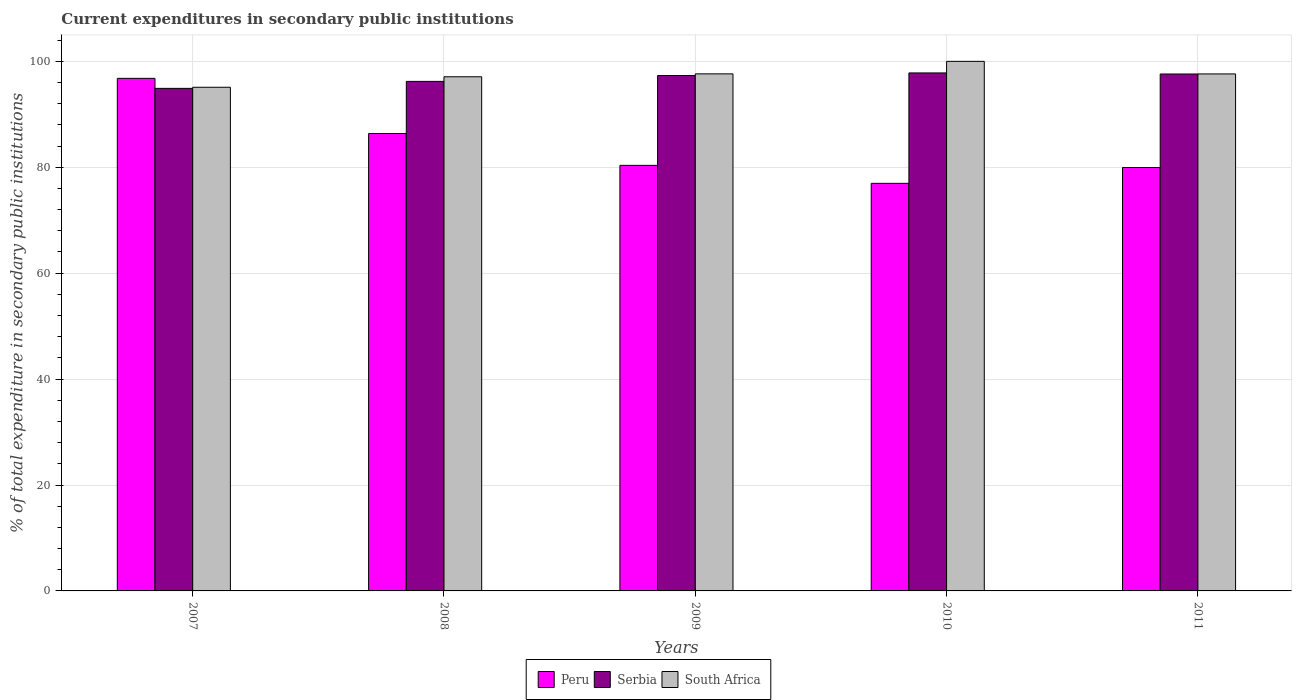How many different coloured bars are there?
Give a very brief answer. 3. Are the number of bars per tick equal to the number of legend labels?
Ensure brevity in your answer.  Yes. How many bars are there on the 3rd tick from the left?
Ensure brevity in your answer.  3. How many bars are there on the 1st tick from the right?
Provide a short and direct response. 3. What is the label of the 5th group of bars from the left?
Keep it short and to the point. 2011. What is the current expenditures in secondary public institutions in Peru in 2007?
Make the answer very short. 96.79. Across all years, what is the maximum current expenditures in secondary public institutions in Peru?
Offer a terse response. 96.79. Across all years, what is the minimum current expenditures in secondary public institutions in Peru?
Provide a succinct answer. 76.97. In which year was the current expenditures in secondary public institutions in Serbia maximum?
Keep it short and to the point. 2010. What is the total current expenditures in secondary public institutions in South Africa in the graph?
Offer a very short reply. 487.46. What is the difference between the current expenditures in secondary public institutions in Serbia in 2007 and that in 2009?
Provide a succinct answer. -2.42. What is the difference between the current expenditures in secondary public institutions in Serbia in 2010 and the current expenditures in secondary public institutions in Peru in 2009?
Provide a short and direct response. 17.45. What is the average current expenditures in secondary public institutions in South Africa per year?
Offer a very short reply. 97.49. In the year 2010, what is the difference between the current expenditures in secondary public institutions in South Africa and current expenditures in secondary public institutions in Serbia?
Provide a short and direct response. 2.19. What is the ratio of the current expenditures in secondary public institutions in Peru in 2007 to that in 2008?
Your answer should be compact. 1.12. What is the difference between the highest and the second highest current expenditures in secondary public institutions in Serbia?
Your answer should be compact. 0.21. What is the difference between the highest and the lowest current expenditures in secondary public institutions in Peru?
Your answer should be very brief. 19.82. Is the sum of the current expenditures in secondary public institutions in South Africa in 2007 and 2010 greater than the maximum current expenditures in secondary public institutions in Serbia across all years?
Your response must be concise. Yes. What does the 1st bar from the left in 2008 represents?
Provide a succinct answer. Peru. What does the 1st bar from the right in 2009 represents?
Your answer should be very brief. South Africa. Is it the case that in every year, the sum of the current expenditures in secondary public institutions in Peru and current expenditures in secondary public institutions in Serbia is greater than the current expenditures in secondary public institutions in South Africa?
Offer a very short reply. Yes. Are all the bars in the graph horizontal?
Your answer should be very brief. No. What is the difference between two consecutive major ticks on the Y-axis?
Your answer should be compact. 20. Does the graph contain any zero values?
Provide a short and direct response. No. Where does the legend appear in the graph?
Provide a succinct answer. Bottom center. What is the title of the graph?
Offer a very short reply. Current expenditures in secondary public institutions. What is the label or title of the X-axis?
Provide a succinct answer. Years. What is the label or title of the Y-axis?
Your answer should be very brief. % of total expenditure in secondary public institutions. What is the % of total expenditure in secondary public institutions of Peru in 2007?
Offer a terse response. 96.79. What is the % of total expenditure in secondary public institutions of Serbia in 2007?
Make the answer very short. 94.9. What is the % of total expenditure in secondary public institutions of South Africa in 2007?
Your answer should be very brief. 95.11. What is the % of total expenditure in secondary public institutions in Peru in 2008?
Offer a terse response. 86.38. What is the % of total expenditure in secondary public institutions in Serbia in 2008?
Keep it short and to the point. 96.22. What is the % of total expenditure in secondary public institutions of South Africa in 2008?
Provide a succinct answer. 97.09. What is the % of total expenditure in secondary public institutions of Peru in 2009?
Provide a succinct answer. 80.36. What is the % of total expenditure in secondary public institutions of Serbia in 2009?
Give a very brief answer. 97.32. What is the % of total expenditure in secondary public institutions of South Africa in 2009?
Keep it short and to the point. 97.64. What is the % of total expenditure in secondary public institutions of Peru in 2010?
Offer a very short reply. 76.97. What is the % of total expenditure in secondary public institutions in Serbia in 2010?
Make the answer very short. 97.81. What is the % of total expenditure in secondary public institutions of South Africa in 2010?
Your answer should be compact. 100. What is the % of total expenditure in secondary public institutions in Peru in 2011?
Offer a terse response. 79.96. What is the % of total expenditure in secondary public institutions of Serbia in 2011?
Provide a short and direct response. 97.61. What is the % of total expenditure in secondary public institutions in South Africa in 2011?
Provide a succinct answer. 97.63. Across all years, what is the maximum % of total expenditure in secondary public institutions of Peru?
Your answer should be very brief. 96.79. Across all years, what is the maximum % of total expenditure in secondary public institutions of Serbia?
Your answer should be compact. 97.81. Across all years, what is the maximum % of total expenditure in secondary public institutions of South Africa?
Make the answer very short. 100. Across all years, what is the minimum % of total expenditure in secondary public institutions of Peru?
Provide a succinct answer. 76.97. Across all years, what is the minimum % of total expenditure in secondary public institutions of Serbia?
Your answer should be very brief. 94.9. Across all years, what is the minimum % of total expenditure in secondary public institutions in South Africa?
Give a very brief answer. 95.11. What is the total % of total expenditure in secondary public institutions in Peru in the graph?
Give a very brief answer. 420.45. What is the total % of total expenditure in secondary public institutions in Serbia in the graph?
Offer a terse response. 483.86. What is the total % of total expenditure in secondary public institutions of South Africa in the graph?
Your answer should be very brief. 487.46. What is the difference between the % of total expenditure in secondary public institutions of Peru in 2007 and that in 2008?
Your answer should be very brief. 10.41. What is the difference between the % of total expenditure in secondary public institutions of Serbia in 2007 and that in 2008?
Provide a short and direct response. -1.32. What is the difference between the % of total expenditure in secondary public institutions in South Africa in 2007 and that in 2008?
Offer a very short reply. -1.98. What is the difference between the % of total expenditure in secondary public institutions in Peru in 2007 and that in 2009?
Give a very brief answer. 16.43. What is the difference between the % of total expenditure in secondary public institutions of Serbia in 2007 and that in 2009?
Your response must be concise. -2.42. What is the difference between the % of total expenditure in secondary public institutions in South Africa in 2007 and that in 2009?
Ensure brevity in your answer.  -2.53. What is the difference between the % of total expenditure in secondary public institutions in Peru in 2007 and that in 2010?
Provide a short and direct response. 19.82. What is the difference between the % of total expenditure in secondary public institutions of Serbia in 2007 and that in 2010?
Give a very brief answer. -2.92. What is the difference between the % of total expenditure in secondary public institutions of South Africa in 2007 and that in 2010?
Your answer should be compact. -4.89. What is the difference between the % of total expenditure in secondary public institutions of Peru in 2007 and that in 2011?
Keep it short and to the point. 16.83. What is the difference between the % of total expenditure in secondary public institutions in Serbia in 2007 and that in 2011?
Ensure brevity in your answer.  -2.71. What is the difference between the % of total expenditure in secondary public institutions of South Africa in 2007 and that in 2011?
Make the answer very short. -2.52. What is the difference between the % of total expenditure in secondary public institutions of Peru in 2008 and that in 2009?
Offer a very short reply. 6.02. What is the difference between the % of total expenditure in secondary public institutions in Serbia in 2008 and that in 2009?
Ensure brevity in your answer.  -1.11. What is the difference between the % of total expenditure in secondary public institutions of South Africa in 2008 and that in 2009?
Make the answer very short. -0.55. What is the difference between the % of total expenditure in secondary public institutions in Peru in 2008 and that in 2010?
Make the answer very short. 9.41. What is the difference between the % of total expenditure in secondary public institutions of Serbia in 2008 and that in 2010?
Provide a succinct answer. -1.6. What is the difference between the % of total expenditure in secondary public institutions of South Africa in 2008 and that in 2010?
Provide a short and direct response. -2.91. What is the difference between the % of total expenditure in secondary public institutions of Peru in 2008 and that in 2011?
Offer a terse response. 6.42. What is the difference between the % of total expenditure in secondary public institutions in Serbia in 2008 and that in 2011?
Give a very brief answer. -1.39. What is the difference between the % of total expenditure in secondary public institutions in South Africa in 2008 and that in 2011?
Offer a very short reply. -0.54. What is the difference between the % of total expenditure in secondary public institutions in Peru in 2009 and that in 2010?
Ensure brevity in your answer.  3.4. What is the difference between the % of total expenditure in secondary public institutions of Serbia in 2009 and that in 2010?
Your response must be concise. -0.49. What is the difference between the % of total expenditure in secondary public institutions in South Africa in 2009 and that in 2010?
Your response must be concise. -2.36. What is the difference between the % of total expenditure in secondary public institutions in Peru in 2009 and that in 2011?
Your answer should be compact. 0.4. What is the difference between the % of total expenditure in secondary public institutions in Serbia in 2009 and that in 2011?
Make the answer very short. -0.29. What is the difference between the % of total expenditure in secondary public institutions in South Africa in 2009 and that in 2011?
Your answer should be compact. 0.01. What is the difference between the % of total expenditure in secondary public institutions of Peru in 2010 and that in 2011?
Provide a succinct answer. -2.99. What is the difference between the % of total expenditure in secondary public institutions in Serbia in 2010 and that in 2011?
Give a very brief answer. 0.21. What is the difference between the % of total expenditure in secondary public institutions in South Africa in 2010 and that in 2011?
Your response must be concise. 2.37. What is the difference between the % of total expenditure in secondary public institutions of Peru in 2007 and the % of total expenditure in secondary public institutions of Serbia in 2008?
Make the answer very short. 0.57. What is the difference between the % of total expenditure in secondary public institutions in Peru in 2007 and the % of total expenditure in secondary public institutions in South Africa in 2008?
Give a very brief answer. -0.3. What is the difference between the % of total expenditure in secondary public institutions of Serbia in 2007 and the % of total expenditure in secondary public institutions of South Africa in 2008?
Make the answer very short. -2.19. What is the difference between the % of total expenditure in secondary public institutions of Peru in 2007 and the % of total expenditure in secondary public institutions of Serbia in 2009?
Offer a terse response. -0.53. What is the difference between the % of total expenditure in secondary public institutions in Peru in 2007 and the % of total expenditure in secondary public institutions in South Africa in 2009?
Ensure brevity in your answer.  -0.85. What is the difference between the % of total expenditure in secondary public institutions in Serbia in 2007 and the % of total expenditure in secondary public institutions in South Africa in 2009?
Give a very brief answer. -2.74. What is the difference between the % of total expenditure in secondary public institutions of Peru in 2007 and the % of total expenditure in secondary public institutions of Serbia in 2010?
Your answer should be compact. -1.03. What is the difference between the % of total expenditure in secondary public institutions in Peru in 2007 and the % of total expenditure in secondary public institutions in South Africa in 2010?
Your answer should be compact. -3.21. What is the difference between the % of total expenditure in secondary public institutions of Serbia in 2007 and the % of total expenditure in secondary public institutions of South Africa in 2010?
Your response must be concise. -5.1. What is the difference between the % of total expenditure in secondary public institutions of Peru in 2007 and the % of total expenditure in secondary public institutions of Serbia in 2011?
Provide a succinct answer. -0.82. What is the difference between the % of total expenditure in secondary public institutions in Peru in 2007 and the % of total expenditure in secondary public institutions in South Africa in 2011?
Make the answer very short. -0.84. What is the difference between the % of total expenditure in secondary public institutions in Serbia in 2007 and the % of total expenditure in secondary public institutions in South Africa in 2011?
Make the answer very short. -2.73. What is the difference between the % of total expenditure in secondary public institutions of Peru in 2008 and the % of total expenditure in secondary public institutions of Serbia in 2009?
Provide a succinct answer. -10.95. What is the difference between the % of total expenditure in secondary public institutions in Peru in 2008 and the % of total expenditure in secondary public institutions in South Africa in 2009?
Provide a short and direct response. -11.26. What is the difference between the % of total expenditure in secondary public institutions in Serbia in 2008 and the % of total expenditure in secondary public institutions in South Africa in 2009?
Keep it short and to the point. -1.42. What is the difference between the % of total expenditure in secondary public institutions in Peru in 2008 and the % of total expenditure in secondary public institutions in Serbia in 2010?
Keep it short and to the point. -11.44. What is the difference between the % of total expenditure in secondary public institutions of Peru in 2008 and the % of total expenditure in secondary public institutions of South Africa in 2010?
Make the answer very short. -13.62. What is the difference between the % of total expenditure in secondary public institutions of Serbia in 2008 and the % of total expenditure in secondary public institutions of South Africa in 2010?
Offer a terse response. -3.78. What is the difference between the % of total expenditure in secondary public institutions in Peru in 2008 and the % of total expenditure in secondary public institutions in Serbia in 2011?
Your answer should be compact. -11.23. What is the difference between the % of total expenditure in secondary public institutions of Peru in 2008 and the % of total expenditure in secondary public institutions of South Africa in 2011?
Your answer should be very brief. -11.25. What is the difference between the % of total expenditure in secondary public institutions in Serbia in 2008 and the % of total expenditure in secondary public institutions in South Africa in 2011?
Make the answer very short. -1.41. What is the difference between the % of total expenditure in secondary public institutions of Peru in 2009 and the % of total expenditure in secondary public institutions of Serbia in 2010?
Ensure brevity in your answer.  -17.45. What is the difference between the % of total expenditure in secondary public institutions in Peru in 2009 and the % of total expenditure in secondary public institutions in South Africa in 2010?
Provide a succinct answer. -19.64. What is the difference between the % of total expenditure in secondary public institutions of Serbia in 2009 and the % of total expenditure in secondary public institutions of South Africa in 2010?
Offer a very short reply. -2.68. What is the difference between the % of total expenditure in secondary public institutions in Peru in 2009 and the % of total expenditure in secondary public institutions in Serbia in 2011?
Your answer should be very brief. -17.25. What is the difference between the % of total expenditure in secondary public institutions of Peru in 2009 and the % of total expenditure in secondary public institutions of South Africa in 2011?
Your response must be concise. -17.27. What is the difference between the % of total expenditure in secondary public institutions of Serbia in 2009 and the % of total expenditure in secondary public institutions of South Africa in 2011?
Offer a very short reply. -0.3. What is the difference between the % of total expenditure in secondary public institutions of Peru in 2010 and the % of total expenditure in secondary public institutions of Serbia in 2011?
Make the answer very short. -20.64. What is the difference between the % of total expenditure in secondary public institutions in Peru in 2010 and the % of total expenditure in secondary public institutions in South Africa in 2011?
Provide a succinct answer. -20.66. What is the difference between the % of total expenditure in secondary public institutions in Serbia in 2010 and the % of total expenditure in secondary public institutions in South Africa in 2011?
Ensure brevity in your answer.  0.19. What is the average % of total expenditure in secondary public institutions in Peru per year?
Offer a very short reply. 84.09. What is the average % of total expenditure in secondary public institutions in Serbia per year?
Ensure brevity in your answer.  96.77. What is the average % of total expenditure in secondary public institutions in South Africa per year?
Provide a short and direct response. 97.49. In the year 2007, what is the difference between the % of total expenditure in secondary public institutions in Peru and % of total expenditure in secondary public institutions in Serbia?
Keep it short and to the point. 1.89. In the year 2007, what is the difference between the % of total expenditure in secondary public institutions of Peru and % of total expenditure in secondary public institutions of South Africa?
Keep it short and to the point. 1.68. In the year 2007, what is the difference between the % of total expenditure in secondary public institutions in Serbia and % of total expenditure in secondary public institutions in South Africa?
Offer a terse response. -0.21. In the year 2008, what is the difference between the % of total expenditure in secondary public institutions in Peru and % of total expenditure in secondary public institutions in Serbia?
Give a very brief answer. -9.84. In the year 2008, what is the difference between the % of total expenditure in secondary public institutions in Peru and % of total expenditure in secondary public institutions in South Africa?
Your response must be concise. -10.71. In the year 2008, what is the difference between the % of total expenditure in secondary public institutions in Serbia and % of total expenditure in secondary public institutions in South Africa?
Your answer should be compact. -0.87. In the year 2009, what is the difference between the % of total expenditure in secondary public institutions in Peru and % of total expenditure in secondary public institutions in Serbia?
Offer a terse response. -16.96. In the year 2009, what is the difference between the % of total expenditure in secondary public institutions in Peru and % of total expenditure in secondary public institutions in South Africa?
Keep it short and to the point. -17.28. In the year 2009, what is the difference between the % of total expenditure in secondary public institutions in Serbia and % of total expenditure in secondary public institutions in South Africa?
Give a very brief answer. -0.31. In the year 2010, what is the difference between the % of total expenditure in secondary public institutions in Peru and % of total expenditure in secondary public institutions in Serbia?
Keep it short and to the point. -20.85. In the year 2010, what is the difference between the % of total expenditure in secondary public institutions in Peru and % of total expenditure in secondary public institutions in South Africa?
Give a very brief answer. -23.03. In the year 2010, what is the difference between the % of total expenditure in secondary public institutions in Serbia and % of total expenditure in secondary public institutions in South Africa?
Offer a terse response. -2.19. In the year 2011, what is the difference between the % of total expenditure in secondary public institutions of Peru and % of total expenditure in secondary public institutions of Serbia?
Offer a very short reply. -17.65. In the year 2011, what is the difference between the % of total expenditure in secondary public institutions in Peru and % of total expenditure in secondary public institutions in South Africa?
Your answer should be very brief. -17.67. In the year 2011, what is the difference between the % of total expenditure in secondary public institutions of Serbia and % of total expenditure in secondary public institutions of South Africa?
Provide a succinct answer. -0.02. What is the ratio of the % of total expenditure in secondary public institutions in Peru in 2007 to that in 2008?
Give a very brief answer. 1.12. What is the ratio of the % of total expenditure in secondary public institutions in Serbia in 2007 to that in 2008?
Keep it short and to the point. 0.99. What is the ratio of the % of total expenditure in secondary public institutions of South Africa in 2007 to that in 2008?
Provide a short and direct response. 0.98. What is the ratio of the % of total expenditure in secondary public institutions in Peru in 2007 to that in 2009?
Provide a succinct answer. 1.2. What is the ratio of the % of total expenditure in secondary public institutions in Serbia in 2007 to that in 2009?
Offer a very short reply. 0.98. What is the ratio of the % of total expenditure in secondary public institutions in South Africa in 2007 to that in 2009?
Your answer should be very brief. 0.97. What is the ratio of the % of total expenditure in secondary public institutions in Peru in 2007 to that in 2010?
Your answer should be compact. 1.26. What is the ratio of the % of total expenditure in secondary public institutions in Serbia in 2007 to that in 2010?
Offer a terse response. 0.97. What is the ratio of the % of total expenditure in secondary public institutions of South Africa in 2007 to that in 2010?
Provide a short and direct response. 0.95. What is the ratio of the % of total expenditure in secondary public institutions of Peru in 2007 to that in 2011?
Provide a short and direct response. 1.21. What is the ratio of the % of total expenditure in secondary public institutions of Serbia in 2007 to that in 2011?
Ensure brevity in your answer.  0.97. What is the ratio of the % of total expenditure in secondary public institutions in South Africa in 2007 to that in 2011?
Give a very brief answer. 0.97. What is the ratio of the % of total expenditure in secondary public institutions in Peru in 2008 to that in 2009?
Keep it short and to the point. 1.07. What is the ratio of the % of total expenditure in secondary public institutions in Serbia in 2008 to that in 2009?
Your answer should be compact. 0.99. What is the ratio of the % of total expenditure in secondary public institutions in Peru in 2008 to that in 2010?
Offer a very short reply. 1.12. What is the ratio of the % of total expenditure in secondary public institutions in Serbia in 2008 to that in 2010?
Ensure brevity in your answer.  0.98. What is the ratio of the % of total expenditure in secondary public institutions in South Africa in 2008 to that in 2010?
Your answer should be very brief. 0.97. What is the ratio of the % of total expenditure in secondary public institutions of Peru in 2008 to that in 2011?
Provide a short and direct response. 1.08. What is the ratio of the % of total expenditure in secondary public institutions of Serbia in 2008 to that in 2011?
Offer a very short reply. 0.99. What is the ratio of the % of total expenditure in secondary public institutions of Peru in 2009 to that in 2010?
Offer a terse response. 1.04. What is the ratio of the % of total expenditure in secondary public institutions in Serbia in 2009 to that in 2010?
Provide a short and direct response. 0.99. What is the ratio of the % of total expenditure in secondary public institutions of South Africa in 2009 to that in 2010?
Offer a terse response. 0.98. What is the ratio of the % of total expenditure in secondary public institutions in Peru in 2009 to that in 2011?
Your answer should be compact. 1. What is the ratio of the % of total expenditure in secondary public institutions in Serbia in 2009 to that in 2011?
Keep it short and to the point. 1. What is the ratio of the % of total expenditure in secondary public institutions in Peru in 2010 to that in 2011?
Offer a very short reply. 0.96. What is the ratio of the % of total expenditure in secondary public institutions in South Africa in 2010 to that in 2011?
Provide a succinct answer. 1.02. What is the difference between the highest and the second highest % of total expenditure in secondary public institutions of Peru?
Provide a short and direct response. 10.41. What is the difference between the highest and the second highest % of total expenditure in secondary public institutions in Serbia?
Make the answer very short. 0.21. What is the difference between the highest and the second highest % of total expenditure in secondary public institutions of South Africa?
Your answer should be very brief. 2.36. What is the difference between the highest and the lowest % of total expenditure in secondary public institutions of Peru?
Offer a terse response. 19.82. What is the difference between the highest and the lowest % of total expenditure in secondary public institutions of Serbia?
Provide a succinct answer. 2.92. What is the difference between the highest and the lowest % of total expenditure in secondary public institutions of South Africa?
Make the answer very short. 4.89. 